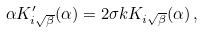Convert formula to latex. <formula><loc_0><loc_0><loc_500><loc_500>\alpha K _ { i \sqrt { \beta } } ^ { \prime } ( \alpha ) = 2 \sigma k K _ { i \sqrt { \beta } } ( \alpha ) \, ,</formula> 